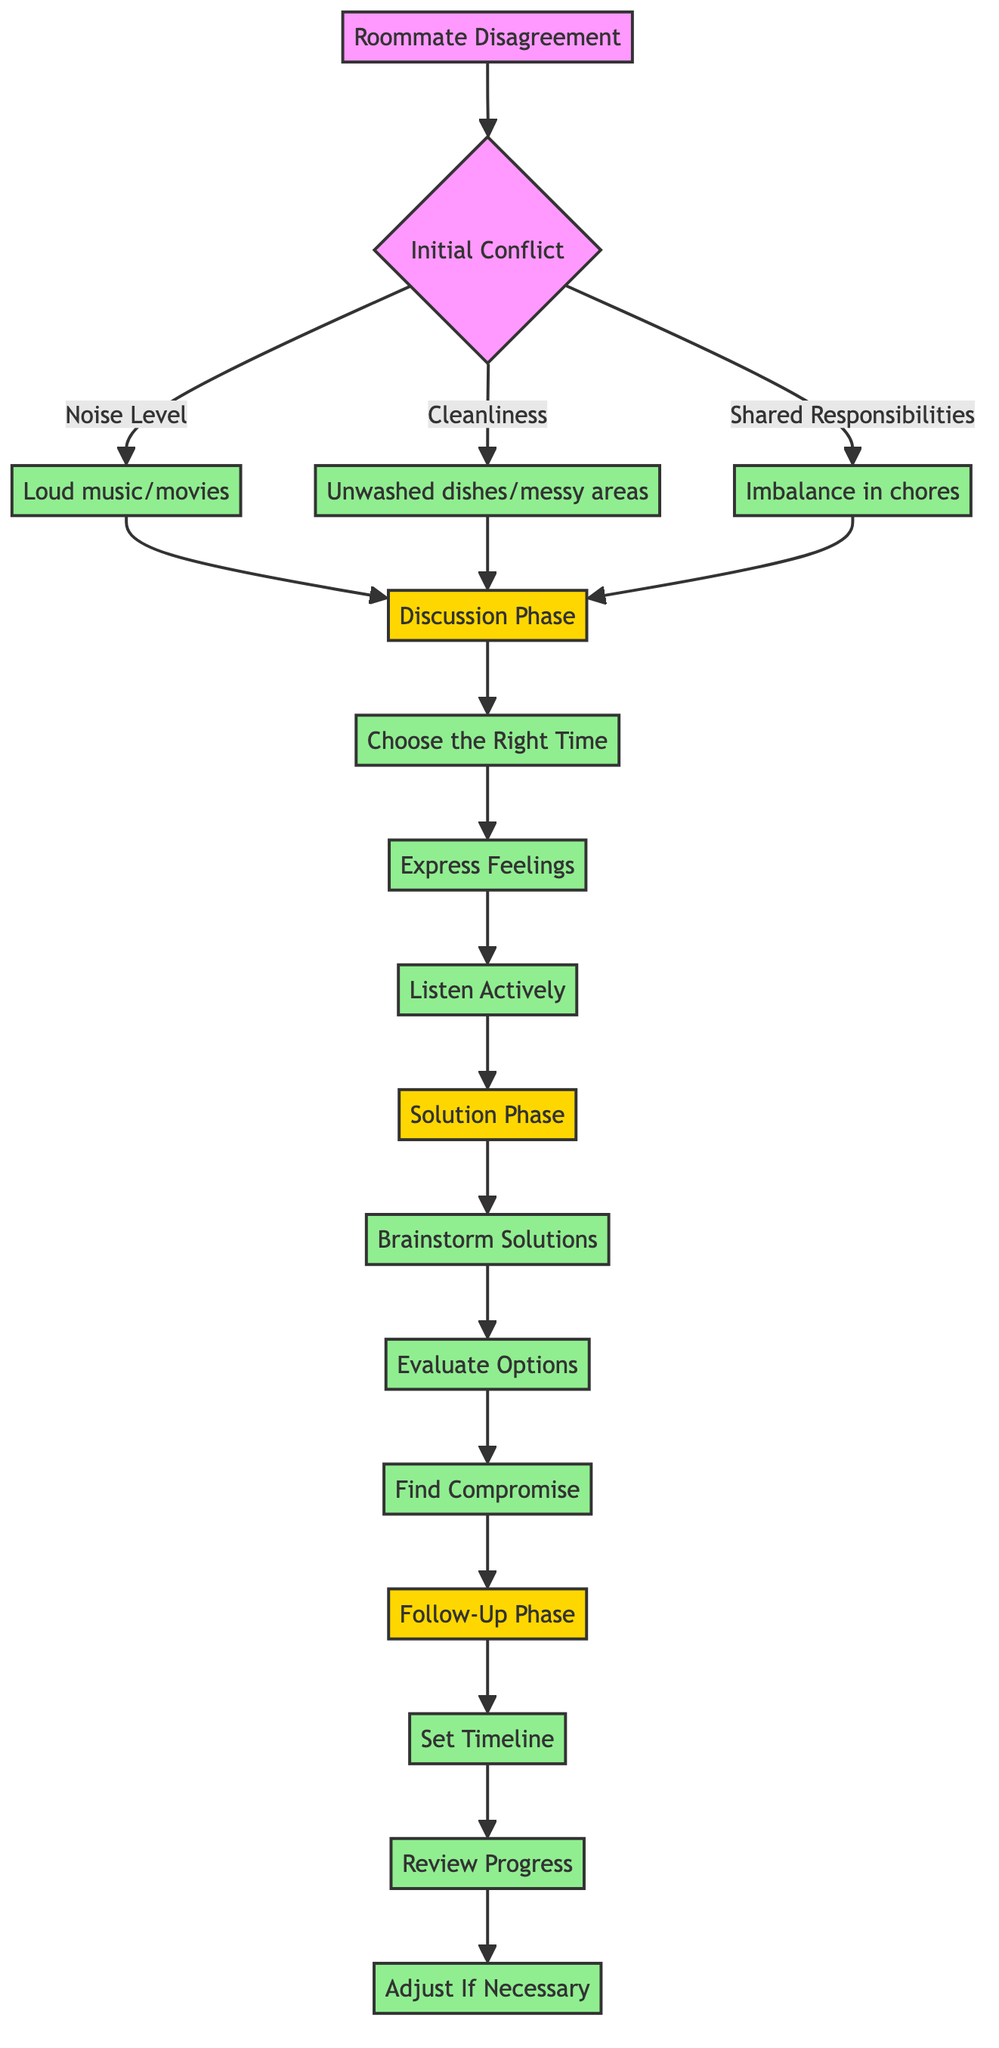What is the first phase in the diagram? The diagram starts with the "Initial Conflict" phase, which outlines the disagreements that can arise between roommates.
Answer: Initial Conflict How many issues are listed under Initial Conflict? There are three specific issues listed in the Initial Conflict phase: Noise Level, Cleanliness, and Shared Responsibilities.
Answer: 3 Which action follows after "Listen Actively"? The next action after "Listen Actively" in the Discussion Phase is "Solution Phase." This leads to the phase where practical solutions and negotiations occur.
Answer: Solution Phase What is the last action in the Follow-Up Phase? The final action in the Follow-Up Phase is "Adjust If Necessary," which ensures that any necessary changes are made to the agreed-upon solution.
Answer: Adjust If Necessary How do the phases connect after the Initial Conflict? After the Initial Conflict, the phases connect sequentially: it goes from Initial Conflict to the Discussion Phase, then to the Solution Phase, and finally to the Follow-Up Phase.
Answer: Sequentially What is the main purpose of the Solution Phase? The main purpose of the Solution Phase is to propose practical solutions and negotiate terms to resolve the disagreement effectively.
Answer: Propose practical solutions Which action in the Follow-Up Phase involves determining when to check back on the situation? The action that involves determining when to check back on the situation is "Set Timeline." This step is crucial for ensuring follow-through on the resolution.
Answer: Set Timeline What type of issues is addressed under Cleanliness? The issues addressed under Cleanliness include leaving dishes unwashed and messy common areas, which directly impact the living situation.
Answer: Unwashed dishes/messy areas How many actions are there in the Discussion Phase? There are three actions listed in the Discussion Phase: Choose the Right Time, Express Feelings, and Listen Actively.
Answer: 3 